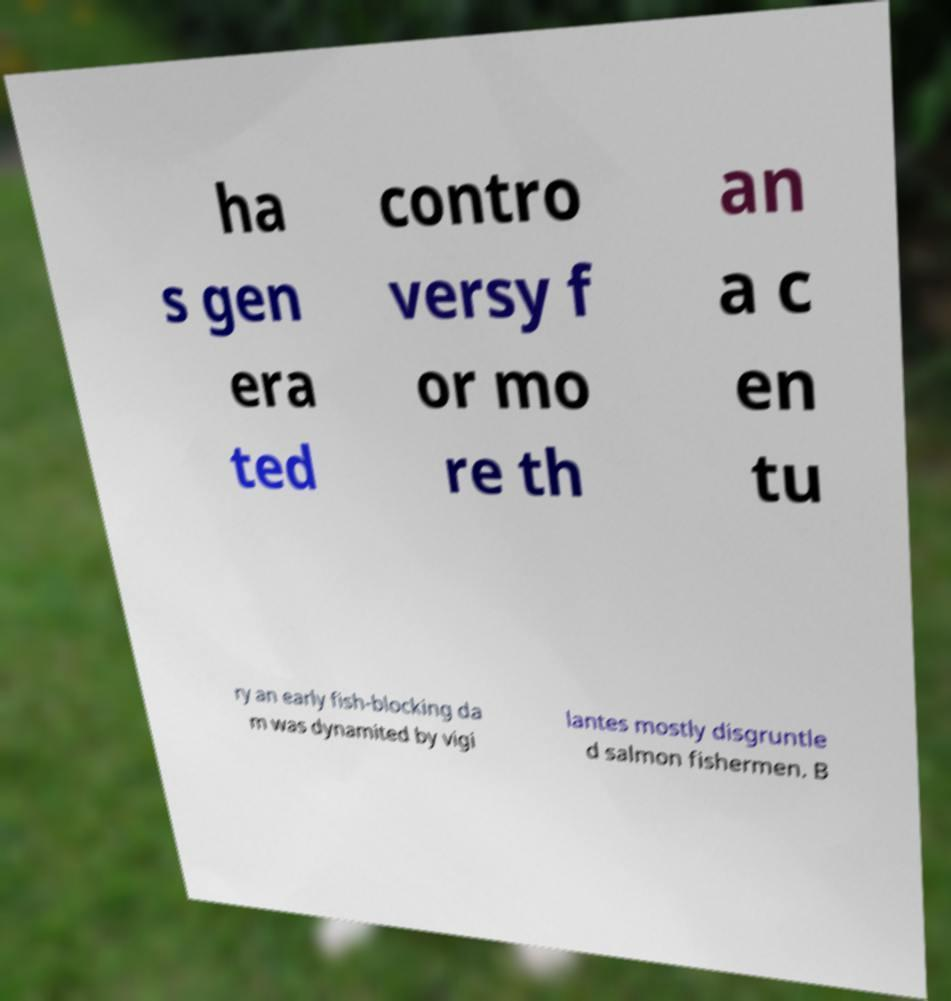Could you assist in decoding the text presented in this image and type it out clearly? ha s gen era ted contro versy f or mo re th an a c en tu ry an early fish-blocking da m was dynamited by vigi lantes mostly disgruntle d salmon fishermen. B 